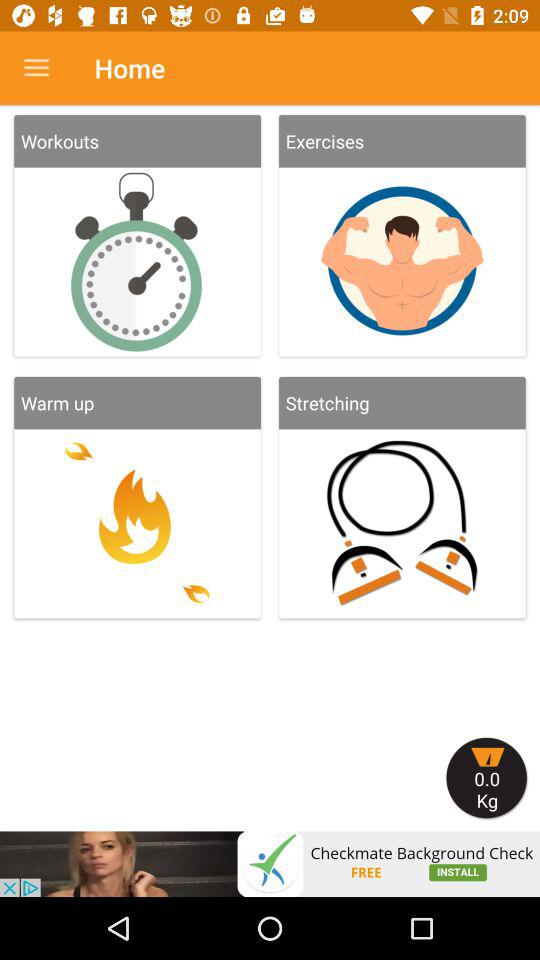Which option is selected?
When the provided information is insufficient, respond with <no answer>. <no answer> 